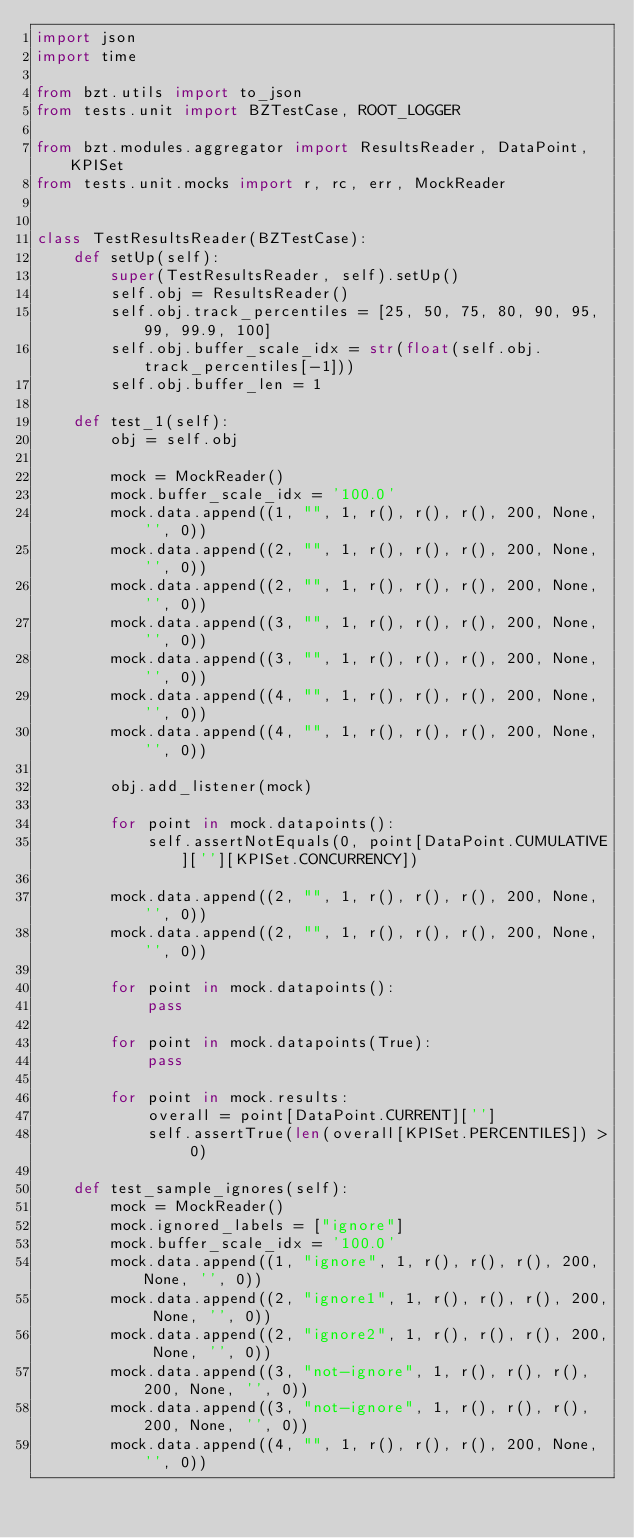Convert code to text. <code><loc_0><loc_0><loc_500><loc_500><_Python_>import json
import time

from bzt.utils import to_json
from tests.unit import BZTestCase, ROOT_LOGGER

from bzt.modules.aggregator import ResultsReader, DataPoint, KPISet
from tests.unit.mocks import r, rc, err, MockReader


class TestResultsReader(BZTestCase):
    def setUp(self):
        super(TestResultsReader, self).setUp()
        self.obj = ResultsReader()
        self.obj.track_percentiles = [25, 50, 75, 80, 90, 95, 99, 99.9, 100]
        self.obj.buffer_scale_idx = str(float(self.obj.track_percentiles[-1]))
        self.obj.buffer_len = 1

    def test_1(self):
        obj = self.obj

        mock = MockReader()
        mock.buffer_scale_idx = '100.0'
        mock.data.append((1, "", 1, r(), r(), r(), 200, None, '', 0))
        mock.data.append((2, "", 1, r(), r(), r(), 200, None, '', 0))
        mock.data.append((2, "", 1, r(), r(), r(), 200, None, '', 0))
        mock.data.append((3, "", 1, r(), r(), r(), 200, None, '', 0))
        mock.data.append((3, "", 1, r(), r(), r(), 200, None, '', 0))
        mock.data.append((4, "", 1, r(), r(), r(), 200, None, '', 0))
        mock.data.append((4, "", 1, r(), r(), r(), 200, None, '', 0))

        obj.add_listener(mock)

        for point in mock.datapoints():
            self.assertNotEquals(0, point[DataPoint.CUMULATIVE][''][KPISet.CONCURRENCY])

        mock.data.append((2, "", 1, r(), r(), r(), 200, None, '', 0))
        mock.data.append((2, "", 1, r(), r(), r(), 200, None, '', 0))

        for point in mock.datapoints():
            pass

        for point in mock.datapoints(True):
            pass

        for point in mock.results:
            overall = point[DataPoint.CURRENT]['']
            self.assertTrue(len(overall[KPISet.PERCENTILES]) > 0)

    def test_sample_ignores(self):
        mock = MockReader()
        mock.ignored_labels = ["ignore"]
        mock.buffer_scale_idx = '100.0'
        mock.data.append((1, "ignore", 1, r(), r(), r(), 200, None, '', 0))
        mock.data.append((2, "ignore1", 1, r(), r(), r(), 200, None, '', 0))
        mock.data.append((2, "ignore2", 1, r(), r(), r(), 200, None, '', 0))
        mock.data.append((3, "not-ignore", 1, r(), r(), r(), 200, None, '', 0))
        mock.data.append((3, "not-ignore", 1, r(), r(), r(), 200, None, '', 0))
        mock.data.append((4, "", 1, r(), r(), r(), 200, None, '', 0))</code> 